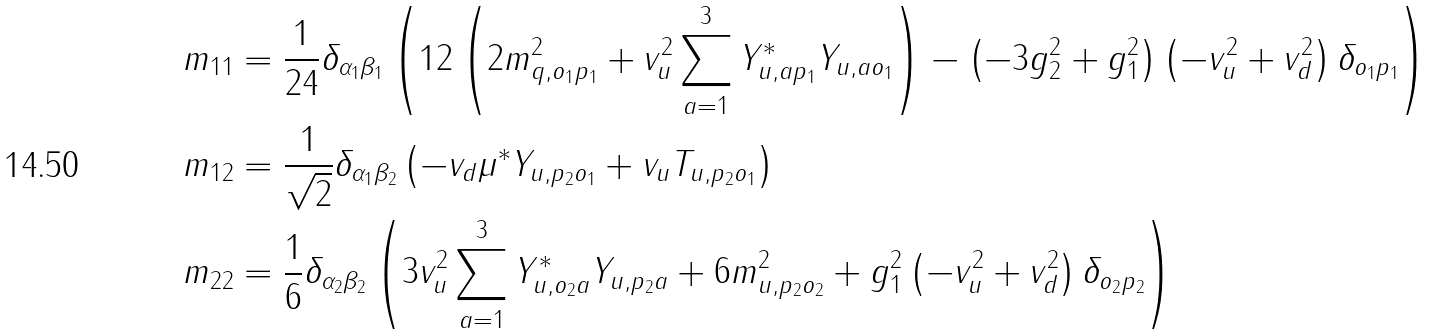<formula> <loc_0><loc_0><loc_500><loc_500>m _ { 1 1 } & = \frac { 1 } { 2 4 } \delta _ { { \alpha _ { 1 } } { \beta _ { 1 } } } \left ( 1 2 \left ( 2 m _ { q , { { o _ { 1 } } { p _ { 1 } } } } ^ { 2 } + v _ { u } ^ { 2 } \sum _ { a = 1 } ^ { 3 } Y ^ { * } _ { u , { a { p _ { 1 } } } } Y _ { u , { a { o _ { 1 } } } } \right ) - \left ( - 3 g _ { 2 } ^ { 2 } + g _ { 1 } ^ { 2 } \right ) \left ( - v _ { u } ^ { 2 } + v _ { d } ^ { 2 } \right ) \delta _ { { o _ { 1 } } { p _ { 1 } } } \right ) \\ m _ { 1 2 } & = \frac { 1 } { \sqrt { 2 } } \delta _ { { \alpha _ { 1 } } { \beta _ { 2 } } } \left ( - v _ { d } \mu ^ { * } Y _ { u , { { p _ { 2 } } { o _ { 1 } } } } + v _ { u } T _ { u , { { p _ { 2 } } { o _ { 1 } } } } \right ) \\ m _ { 2 2 } & = \frac { 1 } { 6 } \delta _ { { \alpha _ { 2 } } { \beta _ { 2 } } } \left ( 3 v _ { u } ^ { 2 } \sum _ { a = 1 } ^ { 3 } Y ^ { * } _ { u , { { o _ { 2 } } a } } Y _ { u , { { p _ { 2 } } a } } + 6 m _ { u , { { p _ { 2 } } { o _ { 2 } } } } ^ { 2 } + g _ { 1 } ^ { 2 } \left ( - v _ { u } ^ { 2 } + v _ { d } ^ { 2 } \right ) \delta _ { { o _ { 2 } } { p _ { 2 } } } \right )</formula> 